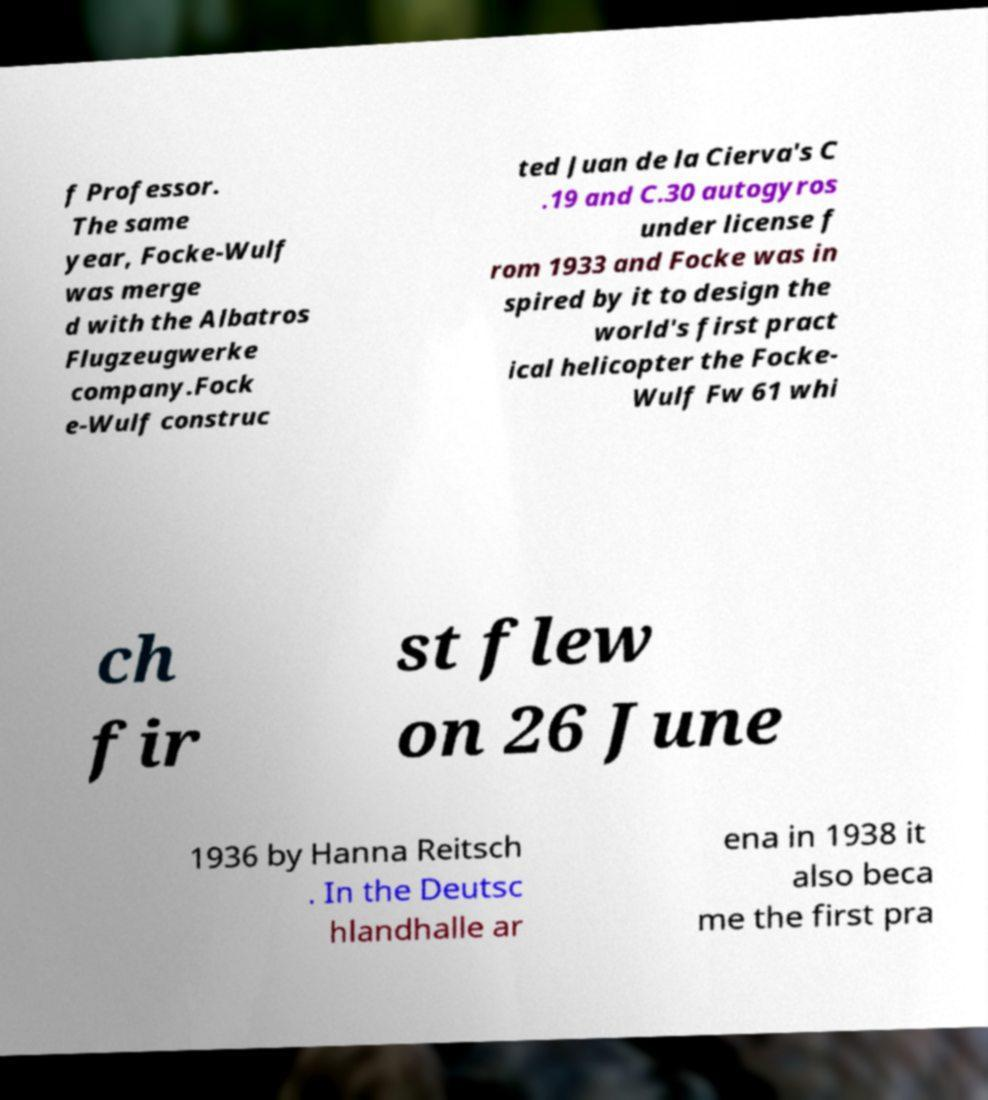Please read and relay the text visible in this image. What does it say? f Professor. The same year, Focke-Wulf was merge d with the Albatros Flugzeugwerke company.Fock e-Wulf construc ted Juan de la Cierva's C .19 and C.30 autogyros under license f rom 1933 and Focke was in spired by it to design the world's first pract ical helicopter the Focke- Wulf Fw 61 whi ch fir st flew on 26 June 1936 by Hanna Reitsch . In the Deutsc hlandhalle ar ena in 1938 it also beca me the first pra 